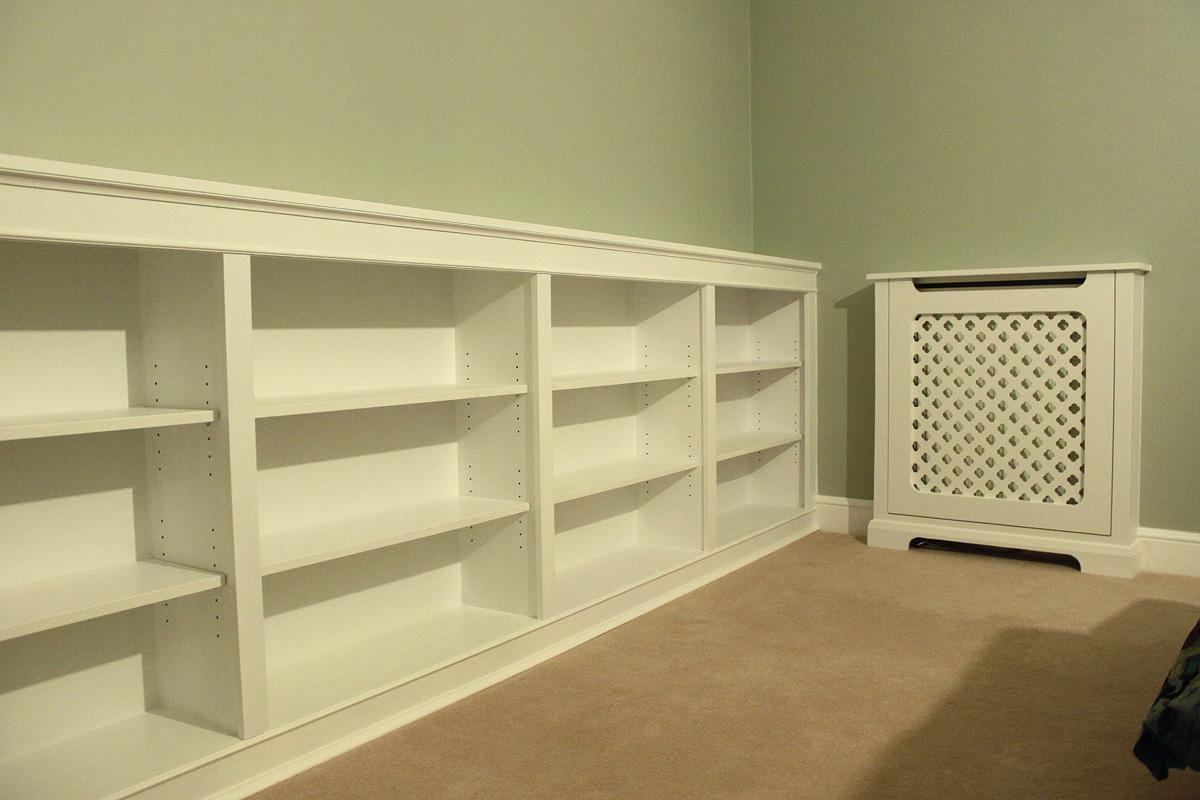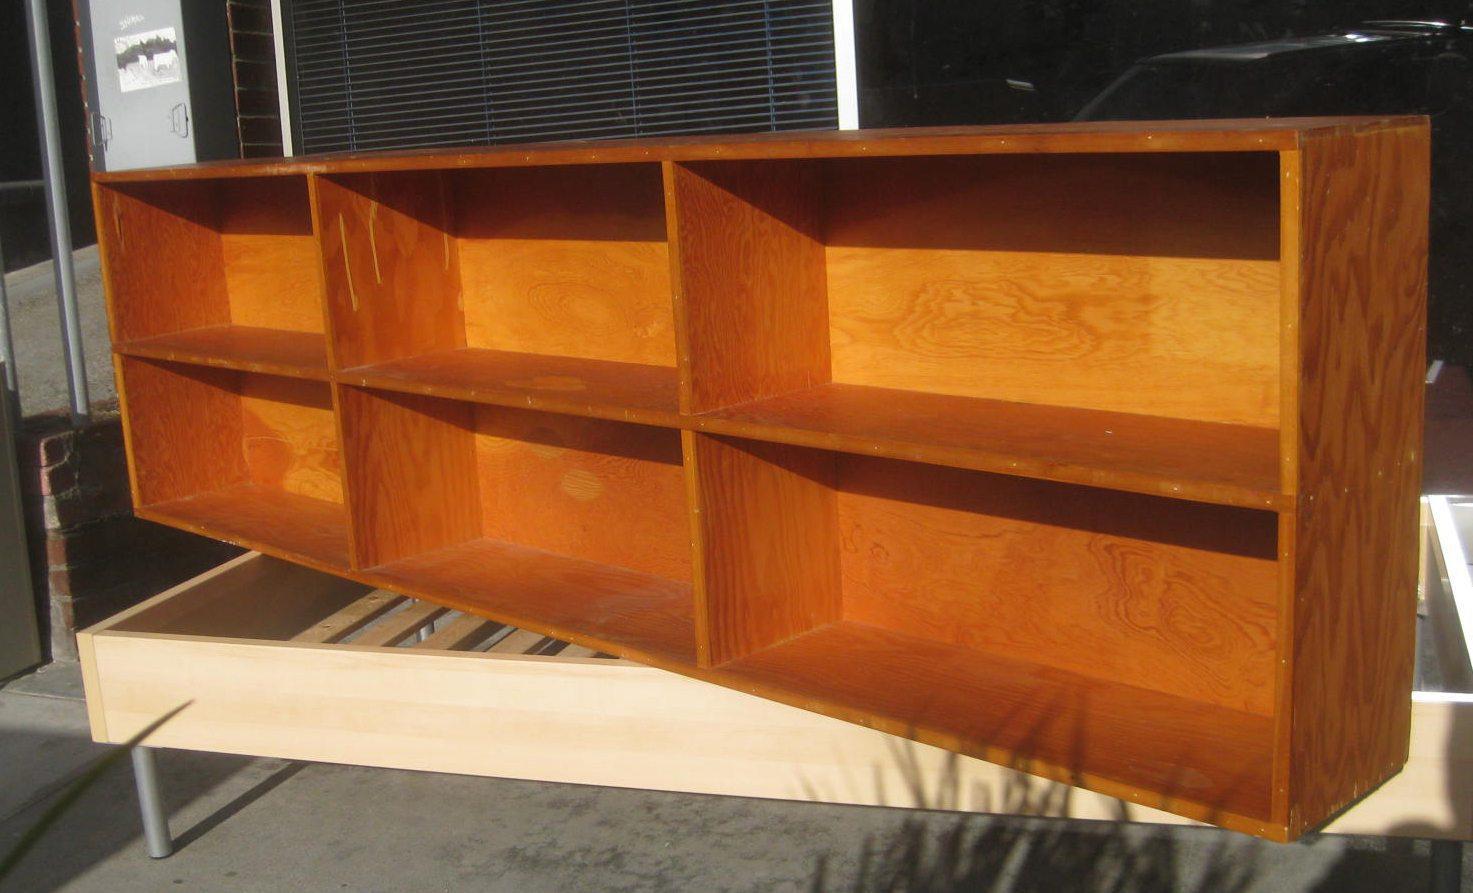The first image is the image on the left, the second image is the image on the right. Considering the images on both sides, is "There is something on the top and inside of a horizontal bookshelf unit, in one image." valid? Answer yes or no. No. 